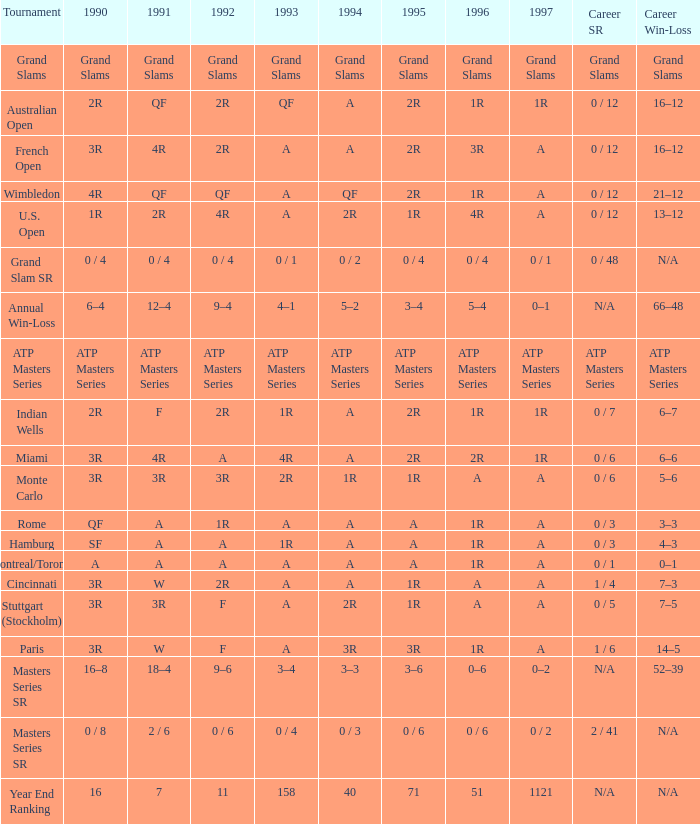What is 1996, when 1992 is "atp masters series"? ATP Masters Series. 